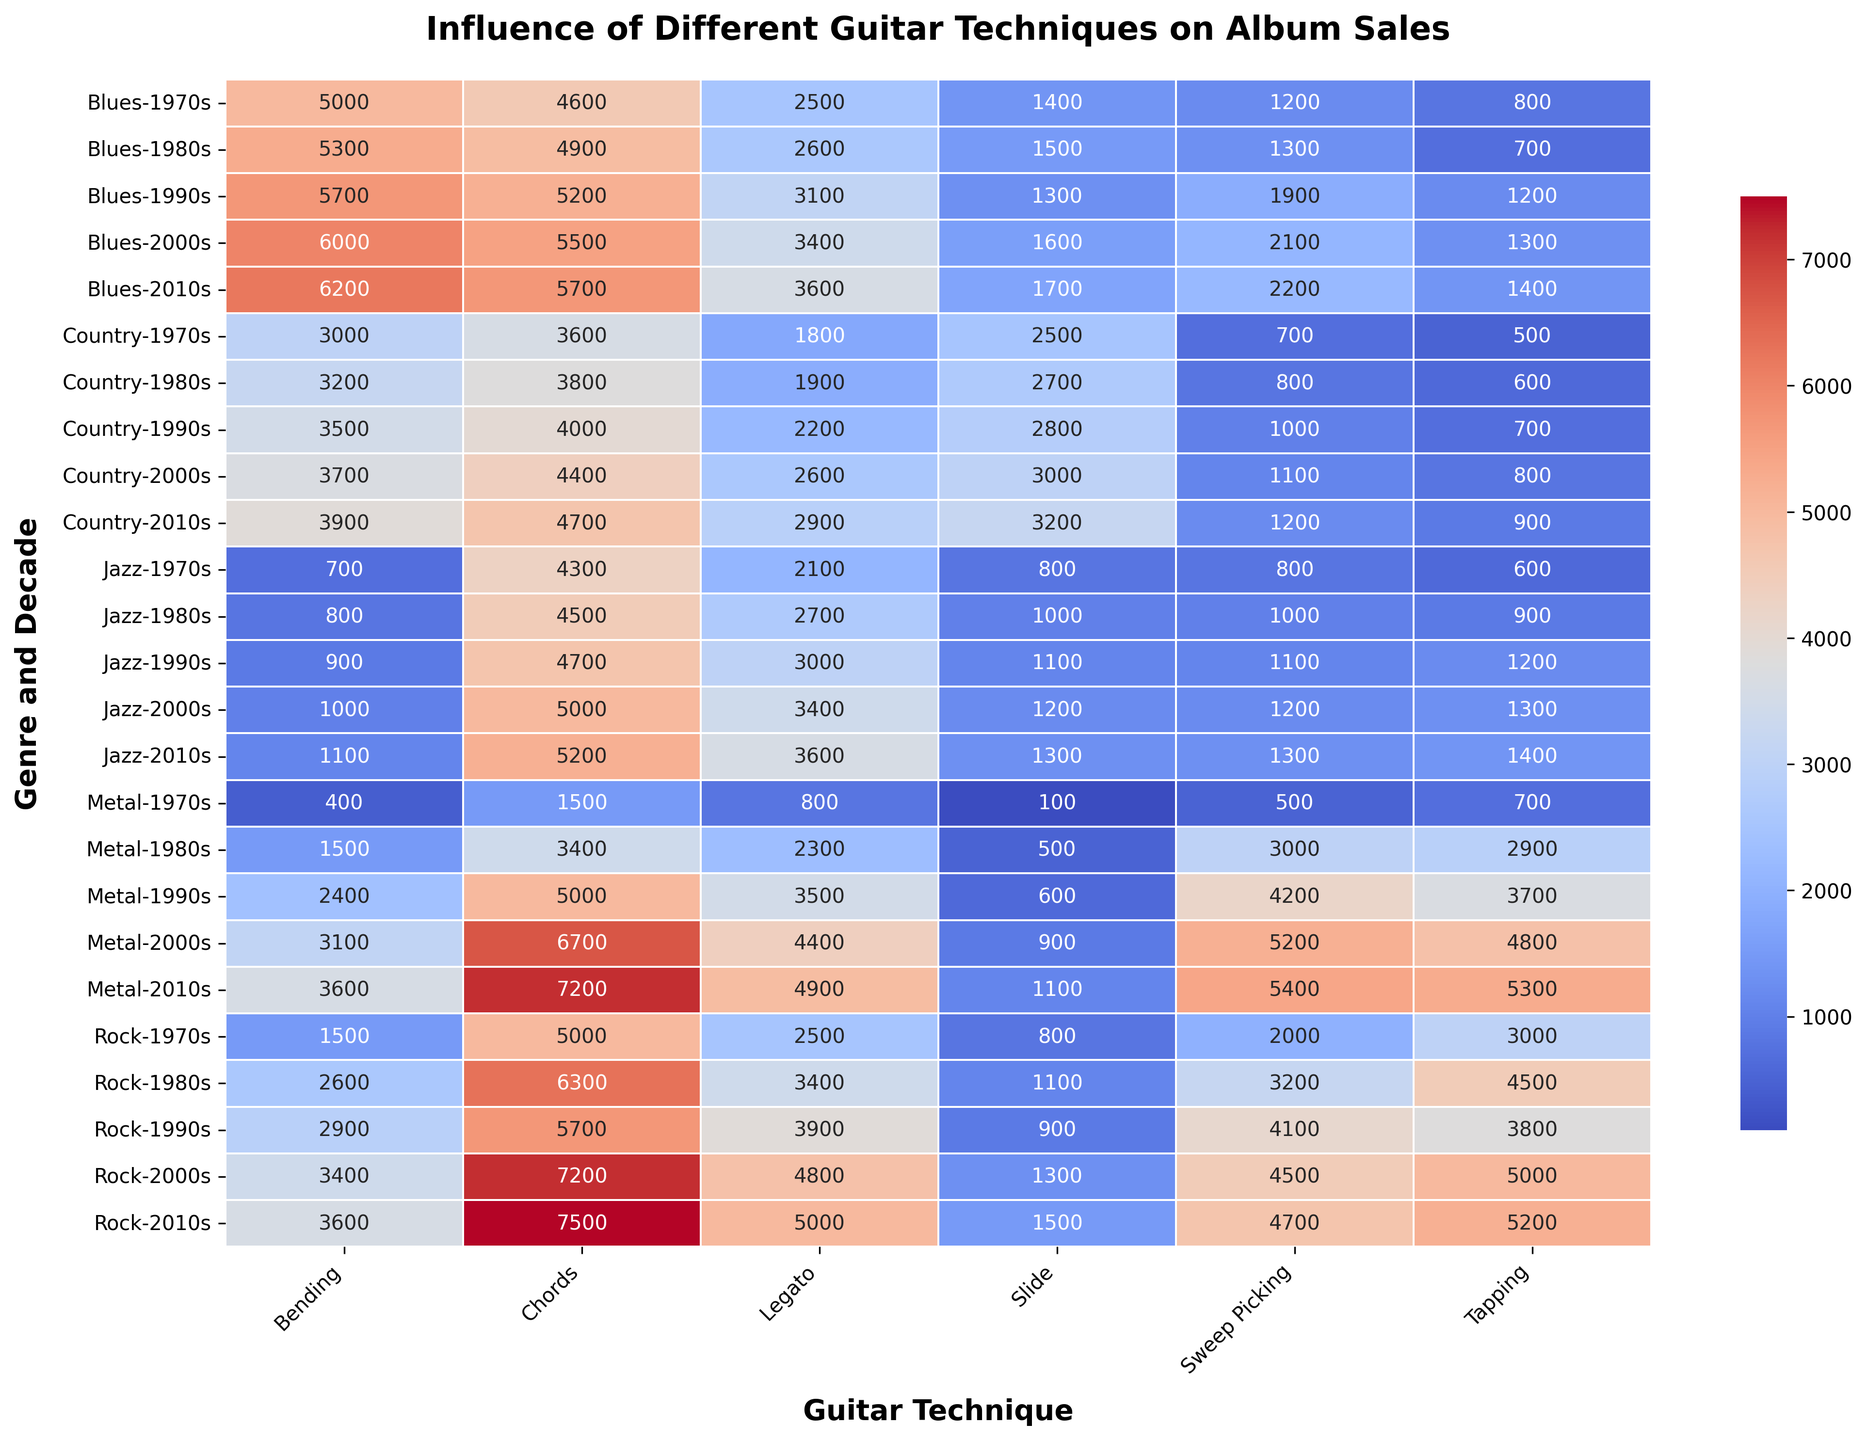What decade and genre combination had the highest album sales for Sweep Picking? Review the "Sweep Picking" column for the highest value and trace it back to the respective row for genre and decade. The highest value in "Sweep Picking" is 5400, which corresponds to Metal, 2010s.
Answer: Metal, 2010s Which guitar technique had the most consistent album sales across all decades within the Jazz genre? Examine the Jazz rows for each decade and compare the variability of sales across different techniques. Noting the relatively stable album sales, "Chords" shows consistent values: 4300, 4500, 4700, 5000, and 5200.
Answer: Chords How did bending influence album sales in the Country genre from the 1970s to the 2010s? Look at the "Bending" column within the Country genre across all listed decades (1970s-2010s). The values are: 3000, 3200, 3500, 3700, and 3900, showing a steady increase.
Answer: Steady increase During which decade did the Rock genre witness the highest sales influenced by Tapping? Check the "Tapping" values for the Rock genre across the decades. The highest value is 5200 in the 2010s.
Answer: 2010s Which genre had the lowest album sales influenced by Slide in the 2000s? Compare values in the "Slide" column for each genre in the 2000s. The lowest value is in Country, with 3000 album sales.
Answer: Country Calculate the average influence of Legato on album sales for the Blues genre during the 1990s and 2000s. Find the Legato values in the Blues genre for these decades: 1990s (3100) and 2000s (3400). Average: (3100 + 3400) / 2 = 3250.
Answer: 3250 Compare the influence of Chords on album sales in the 1970s between Jazz and Blues. Which genre had higher sales? Check the "Chords" values in the 1970s for Jazz (4300) and Blues (4600). Blues had higher sales.
Answer: Blues Which guitar technique shows the most significant increase in influence on album sales within the Metal genre from the 1970s to the 2010s? Calculate the increase for each technique by subtracting the 1970s value from the 2010s value in the Metal genre. "Sweep Picking": (5400 - 500) = 4900, showing the most significant increase.
Answer: Sweep Picking Determine the total album sales influenced by Sliding in all decades for the Country genre. Sum the Slide values for the Country genre across all decades: 2500 + 2700 + 2800 + 3000 + 3200 = 14200.
Answer: 14200 